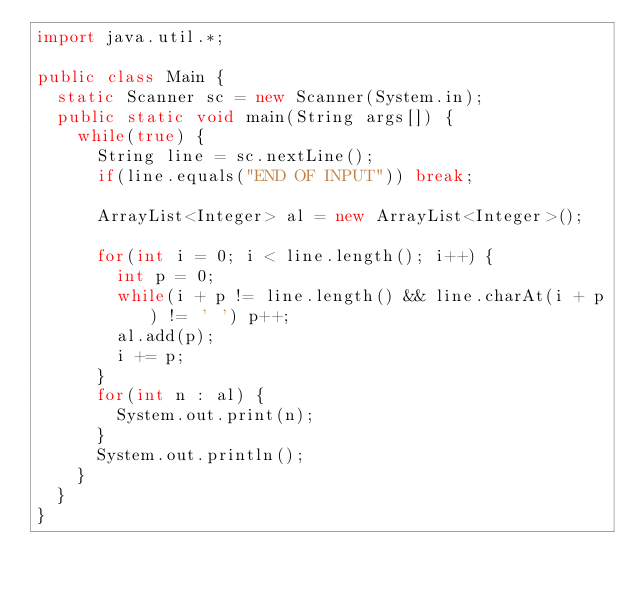<code> <loc_0><loc_0><loc_500><loc_500><_Java_>import java.util.*;

public class Main {
	static Scanner sc = new Scanner(System.in);
	public static void main(String args[]) {
		while(true) {
			String line = sc.nextLine();
			if(line.equals("END OF INPUT")) break;

			ArrayList<Integer> al = new ArrayList<Integer>();

			for(int i = 0; i < line.length(); i++) {
				int p = 0;
				while(i + p != line.length() && line.charAt(i + p) != ' ') p++;
				al.add(p);
				i += p;
			}
			for(int n : al) {
				System.out.print(n);
			}
			System.out.println();
		}
	}
}</code> 